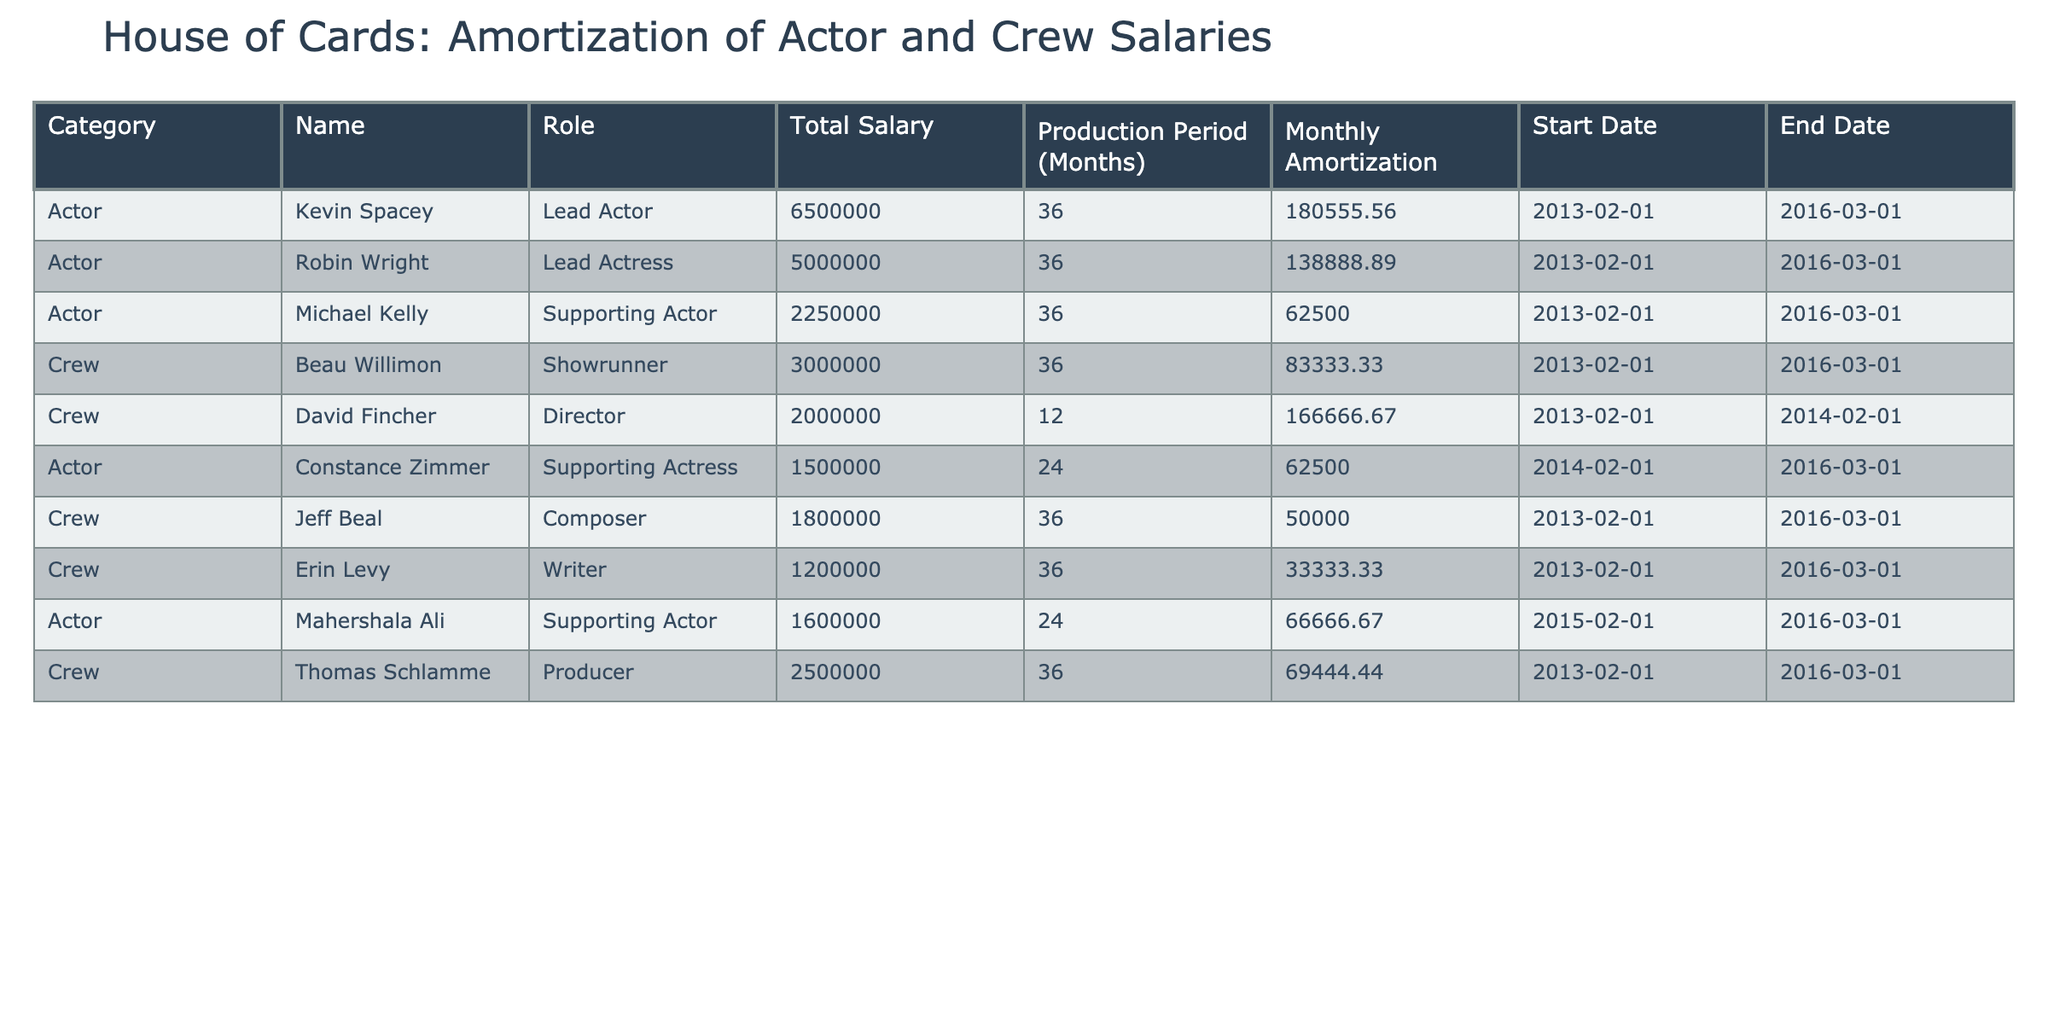What is the total salary allocated to the lead actors? The lead actors listed are Kevin Spacey and Robin Wright. Their total salaries are $6,500,000 and $5,000,000 respectively. Adding these amounts gives us $6,500,000 + $5,000,000 = $11,500,000 as the total.
Answer: 11,500,000 How many months did David Fincher work on the production? David Fincher, the director, had a production period of 12 months, as indicated in the table under the 'Production Period (Months)' column.
Answer: 12 Is the monthly amortization for Constance Zimmer higher than that for Michael Kelly? Constance Zimmer's monthly amortization is $62,500, and Michael Kelly's is also $62,500. Since both values are equal, the answer is no.
Answer: No What is the average monthly amortization for the crew members listed? The crew members listed are Beau Willimon, David Fincher, Jeff Beal, Erin Levy, and Thomas Schlamme. Their monthly amortizations are $83,333.33, $166,666.67, $50,000.00, $33,333.33, and $69,444.44 respectively. The sum is $83,333.33 + $166,666.67 + $50,000.00 + $33,333.33 + $69,444.44 = $402,777.77. Dividing by the number of crew (5) gives us $402,777.77 / 5 = $80,555.55.
Answer: 80,555.55 How much did Mahershala Ali earn in total during his production period? Mahershala Ali's total salary is listed as $1,600,000. This is a straightforward retrieval from the 'Total Salary' column for his entry in the table.
Answer: 1,600,000 Did any crew member have a lower monthly amortization than the supporting actress Constance Zimmer? Constance Zimmer's monthly amortization is $62,500. Amanda's monthly amortization value is $50,000, which is lower. We can see that Jeff Beal, the Composer, has $50,000. Therefore, yes, there is a crew member with lower amortization.
Answer: Yes What is the total duration of the production timeline reflected in the table? The timeline given for the lead actors and most crew members spans from February 1, 2013, to March 1, 2016. This gives a duration of 3 years and 1 month or a total of 37 months.
Answer: 37 months Which role has the highest total salary among all listed? The highest total salary listed is for Kevin Spacey, the Lead Actor, who earned $6,500,000. We identify this through the 'Total Salary' column and compare the amounts.
Answer: 6,500,000 